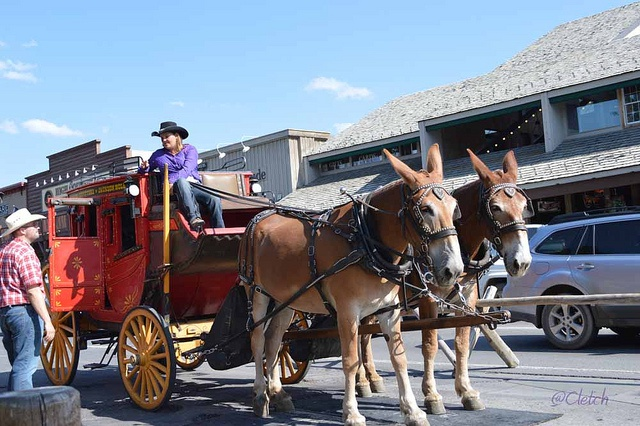Describe the objects in this image and their specific colors. I can see horse in lightblue, black, maroon, and gray tones, car in lightblue, black, and gray tones, horse in lightblue, black, gray, lightgray, and maroon tones, people in lightblue, white, lightpink, gray, and black tones, and people in lightblue, black, violet, navy, and gray tones in this image. 